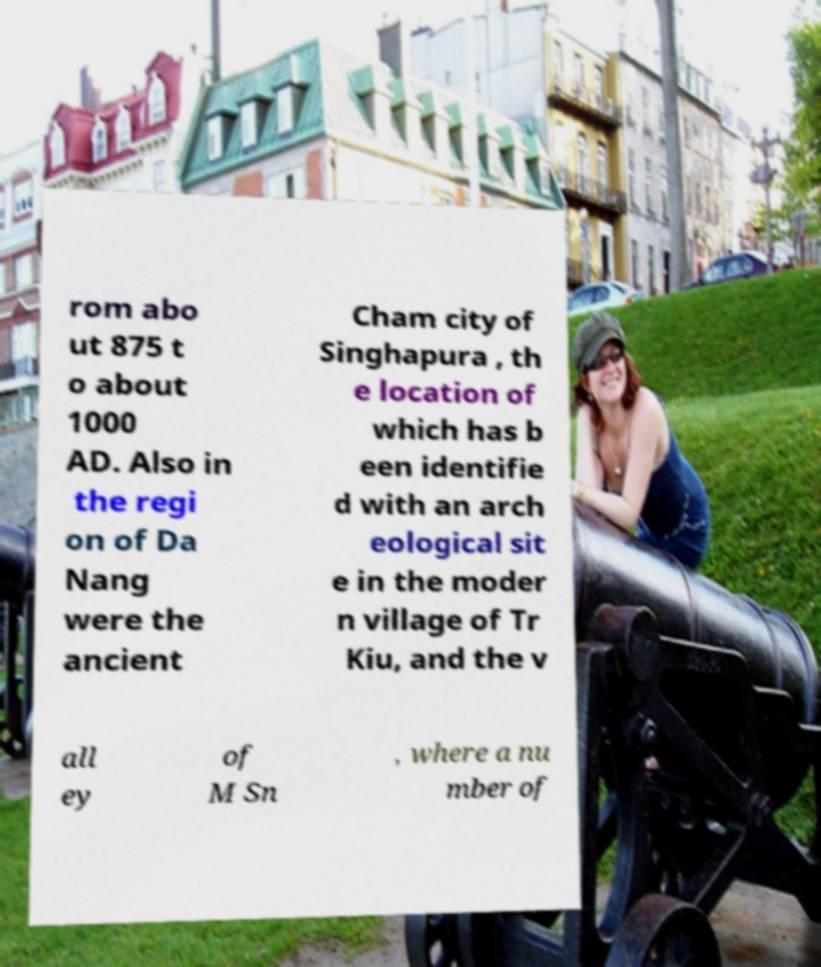Please identify and transcribe the text found in this image. rom abo ut 875 t o about 1000 AD. Also in the regi on of Da Nang were the ancient Cham city of Singhapura , th e location of which has b een identifie d with an arch eological sit e in the moder n village of Tr Kiu, and the v all ey of M Sn , where a nu mber of 